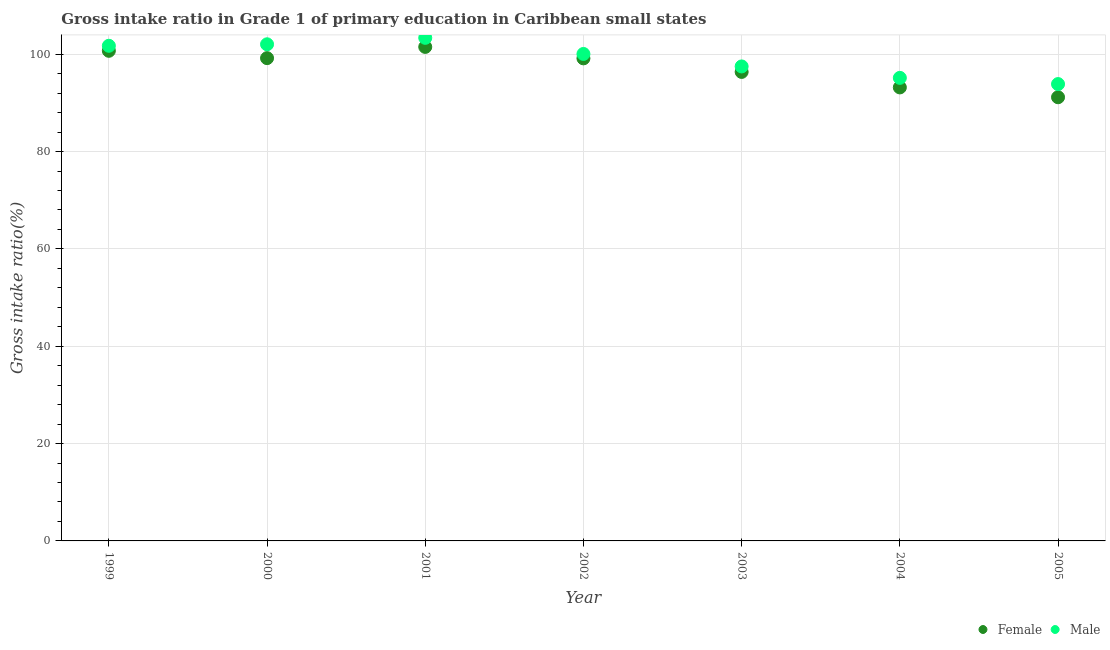How many different coloured dotlines are there?
Provide a short and direct response. 2. What is the gross intake ratio(male) in 2001?
Your answer should be very brief. 103.36. Across all years, what is the maximum gross intake ratio(female)?
Make the answer very short. 101.5. Across all years, what is the minimum gross intake ratio(male)?
Ensure brevity in your answer.  93.86. In which year was the gross intake ratio(male) maximum?
Provide a short and direct response. 2001. In which year was the gross intake ratio(male) minimum?
Give a very brief answer. 2005. What is the total gross intake ratio(female) in the graph?
Ensure brevity in your answer.  681.22. What is the difference between the gross intake ratio(male) in 1999 and that in 2002?
Your answer should be very brief. 1.68. What is the difference between the gross intake ratio(male) in 2001 and the gross intake ratio(female) in 1999?
Keep it short and to the point. 2.66. What is the average gross intake ratio(male) per year?
Ensure brevity in your answer.  99.09. In the year 2001, what is the difference between the gross intake ratio(female) and gross intake ratio(male)?
Your response must be concise. -1.86. In how many years, is the gross intake ratio(female) greater than 84 %?
Give a very brief answer. 7. What is the ratio of the gross intake ratio(male) in 1999 to that in 2004?
Make the answer very short. 1.07. Is the difference between the gross intake ratio(female) in 1999 and 2000 greater than the difference between the gross intake ratio(male) in 1999 and 2000?
Your answer should be compact. Yes. What is the difference between the highest and the second highest gross intake ratio(female)?
Give a very brief answer. 0.8. What is the difference between the highest and the lowest gross intake ratio(female)?
Offer a very short reply. 10.34. Is the sum of the gross intake ratio(male) in 1999 and 2003 greater than the maximum gross intake ratio(female) across all years?
Your answer should be very brief. Yes. Is the gross intake ratio(male) strictly greater than the gross intake ratio(female) over the years?
Keep it short and to the point. Yes. How many dotlines are there?
Your response must be concise. 2. What is the difference between two consecutive major ticks on the Y-axis?
Offer a terse response. 20. Does the graph contain grids?
Offer a terse response. Yes. Where does the legend appear in the graph?
Your answer should be compact. Bottom right. How many legend labels are there?
Your answer should be compact. 2. How are the legend labels stacked?
Provide a short and direct response. Horizontal. What is the title of the graph?
Give a very brief answer. Gross intake ratio in Grade 1 of primary education in Caribbean small states. Does "US$" appear as one of the legend labels in the graph?
Your response must be concise. No. What is the label or title of the Y-axis?
Your answer should be compact. Gross intake ratio(%). What is the Gross intake ratio(%) in Female in 1999?
Your answer should be very brief. 100.7. What is the Gross intake ratio(%) in Male in 1999?
Make the answer very short. 101.73. What is the Gross intake ratio(%) of Female in 2000?
Offer a very short reply. 99.19. What is the Gross intake ratio(%) of Male in 2000?
Keep it short and to the point. 102.04. What is the Gross intake ratio(%) of Female in 2001?
Make the answer very short. 101.5. What is the Gross intake ratio(%) in Male in 2001?
Your answer should be very brief. 103.36. What is the Gross intake ratio(%) in Female in 2002?
Offer a very short reply. 99.15. What is the Gross intake ratio(%) of Male in 2002?
Ensure brevity in your answer.  100.05. What is the Gross intake ratio(%) of Female in 2003?
Your answer should be compact. 96.36. What is the Gross intake ratio(%) in Male in 2003?
Keep it short and to the point. 97.49. What is the Gross intake ratio(%) of Female in 2004?
Ensure brevity in your answer.  93.17. What is the Gross intake ratio(%) of Male in 2004?
Make the answer very short. 95.14. What is the Gross intake ratio(%) in Female in 2005?
Your answer should be compact. 91.16. What is the Gross intake ratio(%) in Male in 2005?
Make the answer very short. 93.86. Across all years, what is the maximum Gross intake ratio(%) in Female?
Your response must be concise. 101.5. Across all years, what is the maximum Gross intake ratio(%) of Male?
Give a very brief answer. 103.36. Across all years, what is the minimum Gross intake ratio(%) of Female?
Ensure brevity in your answer.  91.16. Across all years, what is the minimum Gross intake ratio(%) of Male?
Provide a short and direct response. 93.86. What is the total Gross intake ratio(%) in Female in the graph?
Give a very brief answer. 681.22. What is the total Gross intake ratio(%) of Male in the graph?
Offer a terse response. 693.66. What is the difference between the Gross intake ratio(%) of Female in 1999 and that in 2000?
Make the answer very short. 1.5. What is the difference between the Gross intake ratio(%) of Male in 1999 and that in 2000?
Offer a very short reply. -0.31. What is the difference between the Gross intake ratio(%) in Female in 1999 and that in 2001?
Keep it short and to the point. -0.8. What is the difference between the Gross intake ratio(%) of Male in 1999 and that in 2001?
Offer a very short reply. -1.63. What is the difference between the Gross intake ratio(%) of Female in 1999 and that in 2002?
Provide a short and direct response. 1.55. What is the difference between the Gross intake ratio(%) in Male in 1999 and that in 2002?
Offer a very short reply. 1.68. What is the difference between the Gross intake ratio(%) in Female in 1999 and that in 2003?
Provide a succinct answer. 4.34. What is the difference between the Gross intake ratio(%) in Male in 1999 and that in 2003?
Provide a succinct answer. 4.24. What is the difference between the Gross intake ratio(%) of Female in 1999 and that in 2004?
Your answer should be compact. 7.52. What is the difference between the Gross intake ratio(%) in Male in 1999 and that in 2004?
Give a very brief answer. 6.59. What is the difference between the Gross intake ratio(%) in Female in 1999 and that in 2005?
Ensure brevity in your answer.  9.54. What is the difference between the Gross intake ratio(%) of Male in 1999 and that in 2005?
Your response must be concise. 7.87. What is the difference between the Gross intake ratio(%) of Female in 2000 and that in 2001?
Keep it short and to the point. -2.31. What is the difference between the Gross intake ratio(%) in Male in 2000 and that in 2001?
Your response must be concise. -1.32. What is the difference between the Gross intake ratio(%) in Female in 2000 and that in 2002?
Offer a very short reply. 0.05. What is the difference between the Gross intake ratio(%) in Male in 2000 and that in 2002?
Ensure brevity in your answer.  1.99. What is the difference between the Gross intake ratio(%) in Female in 2000 and that in 2003?
Offer a terse response. 2.83. What is the difference between the Gross intake ratio(%) of Male in 2000 and that in 2003?
Give a very brief answer. 4.55. What is the difference between the Gross intake ratio(%) of Female in 2000 and that in 2004?
Ensure brevity in your answer.  6.02. What is the difference between the Gross intake ratio(%) in Male in 2000 and that in 2004?
Provide a succinct answer. 6.9. What is the difference between the Gross intake ratio(%) in Female in 2000 and that in 2005?
Keep it short and to the point. 8.03. What is the difference between the Gross intake ratio(%) of Male in 2000 and that in 2005?
Offer a terse response. 8.17. What is the difference between the Gross intake ratio(%) of Female in 2001 and that in 2002?
Offer a very short reply. 2.35. What is the difference between the Gross intake ratio(%) of Male in 2001 and that in 2002?
Give a very brief answer. 3.31. What is the difference between the Gross intake ratio(%) of Female in 2001 and that in 2003?
Provide a short and direct response. 5.14. What is the difference between the Gross intake ratio(%) in Male in 2001 and that in 2003?
Offer a very short reply. 5.87. What is the difference between the Gross intake ratio(%) of Female in 2001 and that in 2004?
Provide a succinct answer. 8.32. What is the difference between the Gross intake ratio(%) of Male in 2001 and that in 2004?
Offer a terse response. 8.22. What is the difference between the Gross intake ratio(%) in Female in 2001 and that in 2005?
Your answer should be very brief. 10.34. What is the difference between the Gross intake ratio(%) of Male in 2001 and that in 2005?
Give a very brief answer. 9.5. What is the difference between the Gross intake ratio(%) in Female in 2002 and that in 2003?
Your answer should be very brief. 2.79. What is the difference between the Gross intake ratio(%) of Male in 2002 and that in 2003?
Offer a very short reply. 2.56. What is the difference between the Gross intake ratio(%) in Female in 2002 and that in 2004?
Ensure brevity in your answer.  5.97. What is the difference between the Gross intake ratio(%) of Male in 2002 and that in 2004?
Provide a succinct answer. 4.91. What is the difference between the Gross intake ratio(%) of Female in 2002 and that in 2005?
Make the answer very short. 7.99. What is the difference between the Gross intake ratio(%) in Male in 2002 and that in 2005?
Offer a terse response. 6.19. What is the difference between the Gross intake ratio(%) in Female in 2003 and that in 2004?
Your answer should be compact. 3.18. What is the difference between the Gross intake ratio(%) of Male in 2003 and that in 2004?
Provide a succinct answer. 2.35. What is the difference between the Gross intake ratio(%) of Female in 2003 and that in 2005?
Your answer should be very brief. 5.2. What is the difference between the Gross intake ratio(%) of Male in 2003 and that in 2005?
Keep it short and to the point. 3.62. What is the difference between the Gross intake ratio(%) in Female in 2004 and that in 2005?
Your answer should be compact. 2.02. What is the difference between the Gross intake ratio(%) in Male in 2004 and that in 2005?
Give a very brief answer. 1.27. What is the difference between the Gross intake ratio(%) in Female in 1999 and the Gross intake ratio(%) in Male in 2000?
Provide a succinct answer. -1.34. What is the difference between the Gross intake ratio(%) of Female in 1999 and the Gross intake ratio(%) of Male in 2001?
Provide a short and direct response. -2.66. What is the difference between the Gross intake ratio(%) in Female in 1999 and the Gross intake ratio(%) in Male in 2002?
Keep it short and to the point. 0.65. What is the difference between the Gross intake ratio(%) of Female in 1999 and the Gross intake ratio(%) of Male in 2003?
Give a very brief answer. 3.21. What is the difference between the Gross intake ratio(%) of Female in 1999 and the Gross intake ratio(%) of Male in 2004?
Offer a very short reply. 5.56. What is the difference between the Gross intake ratio(%) in Female in 1999 and the Gross intake ratio(%) in Male in 2005?
Make the answer very short. 6.83. What is the difference between the Gross intake ratio(%) of Female in 2000 and the Gross intake ratio(%) of Male in 2001?
Provide a short and direct response. -4.17. What is the difference between the Gross intake ratio(%) of Female in 2000 and the Gross intake ratio(%) of Male in 2002?
Ensure brevity in your answer.  -0.86. What is the difference between the Gross intake ratio(%) in Female in 2000 and the Gross intake ratio(%) in Male in 2003?
Ensure brevity in your answer.  1.71. What is the difference between the Gross intake ratio(%) of Female in 2000 and the Gross intake ratio(%) of Male in 2004?
Provide a short and direct response. 4.06. What is the difference between the Gross intake ratio(%) in Female in 2000 and the Gross intake ratio(%) in Male in 2005?
Offer a very short reply. 5.33. What is the difference between the Gross intake ratio(%) in Female in 2001 and the Gross intake ratio(%) in Male in 2002?
Offer a terse response. 1.45. What is the difference between the Gross intake ratio(%) of Female in 2001 and the Gross intake ratio(%) of Male in 2003?
Give a very brief answer. 4.01. What is the difference between the Gross intake ratio(%) of Female in 2001 and the Gross intake ratio(%) of Male in 2004?
Give a very brief answer. 6.36. What is the difference between the Gross intake ratio(%) of Female in 2001 and the Gross intake ratio(%) of Male in 2005?
Provide a short and direct response. 7.63. What is the difference between the Gross intake ratio(%) in Female in 2002 and the Gross intake ratio(%) in Male in 2003?
Offer a terse response. 1.66. What is the difference between the Gross intake ratio(%) in Female in 2002 and the Gross intake ratio(%) in Male in 2004?
Ensure brevity in your answer.  4.01. What is the difference between the Gross intake ratio(%) in Female in 2002 and the Gross intake ratio(%) in Male in 2005?
Provide a succinct answer. 5.28. What is the difference between the Gross intake ratio(%) of Female in 2003 and the Gross intake ratio(%) of Male in 2004?
Give a very brief answer. 1.22. What is the difference between the Gross intake ratio(%) of Female in 2003 and the Gross intake ratio(%) of Male in 2005?
Give a very brief answer. 2.5. What is the difference between the Gross intake ratio(%) of Female in 2004 and the Gross intake ratio(%) of Male in 2005?
Your response must be concise. -0.69. What is the average Gross intake ratio(%) in Female per year?
Your response must be concise. 97.32. What is the average Gross intake ratio(%) of Male per year?
Provide a succinct answer. 99.09. In the year 1999, what is the difference between the Gross intake ratio(%) of Female and Gross intake ratio(%) of Male?
Give a very brief answer. -1.03. In the year 2000, what is the difference between the Gross intake ratio(%) in Female and Gross intake ratio(%) in Male?
Keep it short and to the point. -2.84. In the year 2001, what is the difference between the Gross intake ratio(%) in Female and Gross intake ratio(%) in Male?
Your answer should be compact. -1.86. In the year 2002, what is the difference between the Gross intake ratio(%) in Female and Gross intake ratio(%) in Male?
Your answer should be compact. -0.9. In the year 2003, what is the difference between the Gross intake ratio(%) of Female and Gross intake ratio(%) of Male?
Provide a short and direct response. -1.13. In the year 2004, what is the difference between the Gross intake ratio(%) of Female and Gross intake ratio(%) of Male?
Your answer should be compact. -1.96. In the year 2005, what is the difference between the Gross intake ratio(%) of Female and Gross intake ratio(%) of Male?
Ensure brevity in your answer.  -2.71. What is the ratio of the Gross intake ratio(%) of Female in 1999 to that in 2000?
Offer a very short reply. 1.02. What is the ratio of the Gross intake ratio(%) of Male in 1999 to that in 2000?
Your response must be concise. 1. What is the ratio of the Gross intake ratio(%) in Female in 1999 to that in 2001?
Your answer should be very brief. 0.99. What is the ratio of the Gross intake ratio(%) in Male in 1999 to that in 2001?
Give a very brief answer. 0.98. What is the ratio of the Gross intake ratio(%) of Female in 1999 to that in 2002?
Your response must be concise. 1.02. What is the ratio of the Gross intake ratio(%) in Male in 1999 to that in 2002?
Ensure brevity in your answer.  1.02. What is the ratio of the Gross intake ratio(%) in Female in 1999 to that in 2003?
Provide a short and direct response. 1.04. What is the ratio of the Gross intake ratio(%) in Male in 1999 to that in 2003?
Keep it short and to the point. 1.04. What is the ratio of the Gross intake ratio(%) in Female in 1999 to that in 2004?
Your answer should be very brief. 1.08. What is the ratio of the Gross intake ratio(%) in Male in 1999 to that in 2004?
Keep it short and to the point. 1.07. What is the ratio of the Gross intake ratio(%) in Female in 1999 to that in 2005?
Your answer should be very brief. 1.1. What is the ratio of the Gross intake ratio(%) of Male in 1999 to that in 2005?
Make the answer very short. 1.08. What is the ratio of the Gross intake ratio(%) of Female in 2000 to that in 2001?
Offer a terse response. 0.98. What is the ratio of the Gross intake ratio(%) of Male in 2000 to that in 2001?
Your answer should be compact. 0.99. What is the ratio of the Gross intake ratio(%) in Female in 2000 to that in 2002?
Provide a succinct answer. 1. What is the ratio of the Gross intake ratio(%) of Male in 2000 to that in 2002?
Give a very brief answer. 1.02. What is the ratio of the Gross intake ratio(%) of Female in 2000 to that in 2003?
Ensure brevity in your answer.  1.03. What is the ratio of the Gross intake ratio(%) of Male in 2000 to that in 2003?
Your answer should be very brief. 1.05. What is the ratio of the Gross intake ratio(%) of Female in 2000 to that in 2004?
Your answer should be very brief. 1.06. What is the ratio of the Gross intake ratio(%) of Male in 2000 to that in 2004?
Offer a terse response. 1.07. What is the ratio of the Gross intake ratio(%) of Female in 2000 to that in 2005?
Offer a very short reply. 1.09. What is the ratio of the Gross intake ratio(%) of Male in 2000 to that in 2005?
Make the answer very short. 1.09. What is the ratio of the Gross intake ratio(%) in Female in 2001 to that in 2002?
Offer a very short reply. 1.02. What is the ratio of the Gross intake ratio(%) in Male in 2001 to that in 2002?
Your response must be concise. 1.03. What is the ratio of the Gross intake ratio(%) in Female in 2001 to that in 2003?
Provide a succinct answer. 1.05. What is the ratio of the Gross intake ratio(%) of Male in 2001 to that in 2003?
Provide a short and direct response. 1.06. What is the ratio of the Gross intake ratio(%) of Female in 2001 to that in 2004?
Offer a terse response. 1.09. What is the ratio of the Gross intake ratio(%) in Male in 2001 to that in 2004?
Your answer should be compact. 1.09. What is the ratio of the Gross intake ratio(%) in Female in 2001 to that in 2005?
Your answer should be compact. 1.11. What is the ratio of the Gross intake ratio(%) of Male in 2001 to that in 2005?
Your answer should be very brief. 1.1. What is the ratio of the Gross intake ratio(%) of Female in 2002 to that in 2003?
Give a very brief answer. 1.03. What is the ratio of the Gross intake ratio(%) of Male in 2002 to that in 2003?
Ensure brevity in your answer.  1.03. What is the ratio of the Gross intake ratio(%) of Female in 2002 to that in 2004?
Your response must be concise. 1.06. What is the ratio of the Gross intake ratio(%) of Male in 2002 to that in 2004?
Keep it short and to the point. 1.05. What is the ratio of the Gross intake ratio(%) of Female in 2002 to that in 2005?
Provide a succinct answer. 1.09. What is the ratio of the Gross intake ratio(%) of Male in 2002 to that in 2005?
Your answer should be compact. 1.07. What is the ratio of the Gross intake ratio(%) of Female in 2003 to that in 2004?
Your response must be concise. 1.03. What is the ratio of the Gross intake ratio(%) of Male in 2003 to that in 2004?
Your response must be concise. 1.02. What is the ratio of the Gross intake ratio(%) of Female in 2003 to that in 2005?
Your answer should be very brief. 1.06. What is the ratio of the Gross intake ratio(%) in Male in 2003 to that in 2005?
Your response must be concise. 1.04. What is the ratio of the Gross intake ratio(%) of Female in 2004 to that in 2005?
Make the answer very short. 1.02. What is the ratio of the Gross intake ratio(%) of Male in 2004 to that in 2005?
Offer a terse response. 1.01. What is the difference between the highest and the second highest Gross intake ratio(%) in Female?
Make the answer very short. 0.8. What is the difference between the highest and the second highest Gross intake ratio(%) in Male?
Provide a short and direct response. 1.32. What is the difference between the highest and the lowest Gross intake ratio(%) of Female?
Your answer should be compact. 10.34. What is the difference between the highest and the lowest Gross intake ratio(%) in Male?
Offer a very short reply. 9.5. 